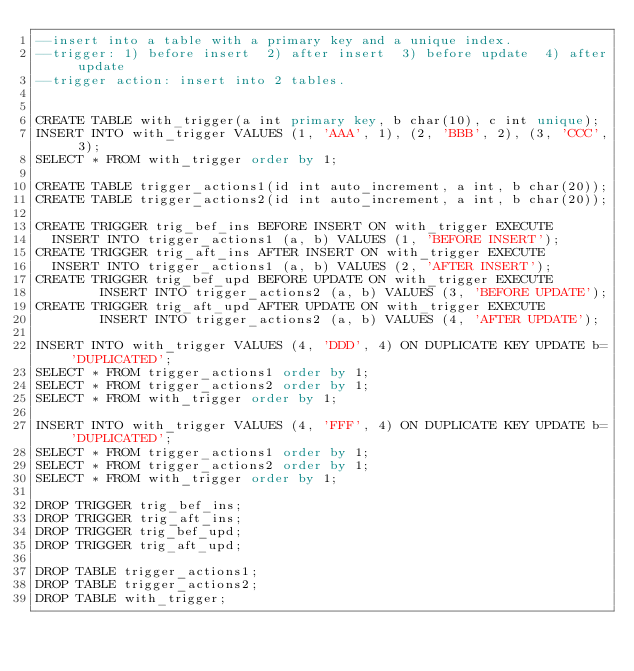Convert code to text. <code><loc_0><loc_0><loc_500><loc_500><_SQL_>--insert into a table with a primary key and a unique index.
--trigger: 1) before insert  2) after insert  3) before update  4) after update
--trigger action: insert into 2 tables.


CREATE TABLE with_trigger(a int primary key, b char(10), c int unique);
INSERT INTO with_trigger VALUES (1, 'AAA', 1), (2, 'BBB', 2), (3, 'CCC', 3);
SELECT * FROM with_trigger order by 1;

CREATE TABLE trigger_actions1(id int auto_increment, a int, b char(20));
CREATE TABLE trigger_actions2(id int auto_increment, a int, b char(20));

CREATE TRIGGER trig_bef_ins BEFORE INSERT ON with_trigger EXECUTE
	INSERT INTO trigger_actions1 (a, b) VALUES (1, 'BEFORE INSERT');
CREATE TRIGGER trig_aft_ins AFTER INSERT ON with_trigger EXECUTE
	INSERT INTO trigger_actions1 (a, b) VALUES (2, 'AFTER INSERT');
CREATE TRIGGER trig_bef_upd BEFORE UPDATE ON with_trigger EXECUTE
        INSERT INTO trigger_actions2 (a, b) VALUES (3, 'BEFORE UPDATE');
CREATE TRIGGER trig_aft_upd AFTER UPDATE ON with_trigger EXECUTE
        INSERT INTO trigger_actions2 (a, b) VALUES (4, 'AFTER UPDATE');

INSERT INTO with_trigger VALUES (4, 'DDD', 4) ON DUPLICATE KEY UPDATE b='DUPLICATED';
SELECT * FROM trigger_actions1 order by 1;
SELECT * FROM trigger_actions2 order by 1;
SELECT * FROM with_trigger order by 1;

INSERT INTO with_trigger VALUES (4, 'FFF', 4) ON DUPLICATE KEY UPDATE b='DUPLICATED';
SELECT * FROM trigger_actions1 order by 1;
SELECT * FROM trigger_actions2 order by 1;
SELECT * FROM with_trigger order by 1;

DROP TRIGGER trig_bef_ins;
DROP TRIGGER trig_aft_ins;
DROP TRIGGER trig_bef_upd;
DROP TRIGGER trig_aft_upd;

DROP TABLE trigger_actions1;
DROP TABLE trigger_actions2;
DROP TABLE with_trigger;
</code> 